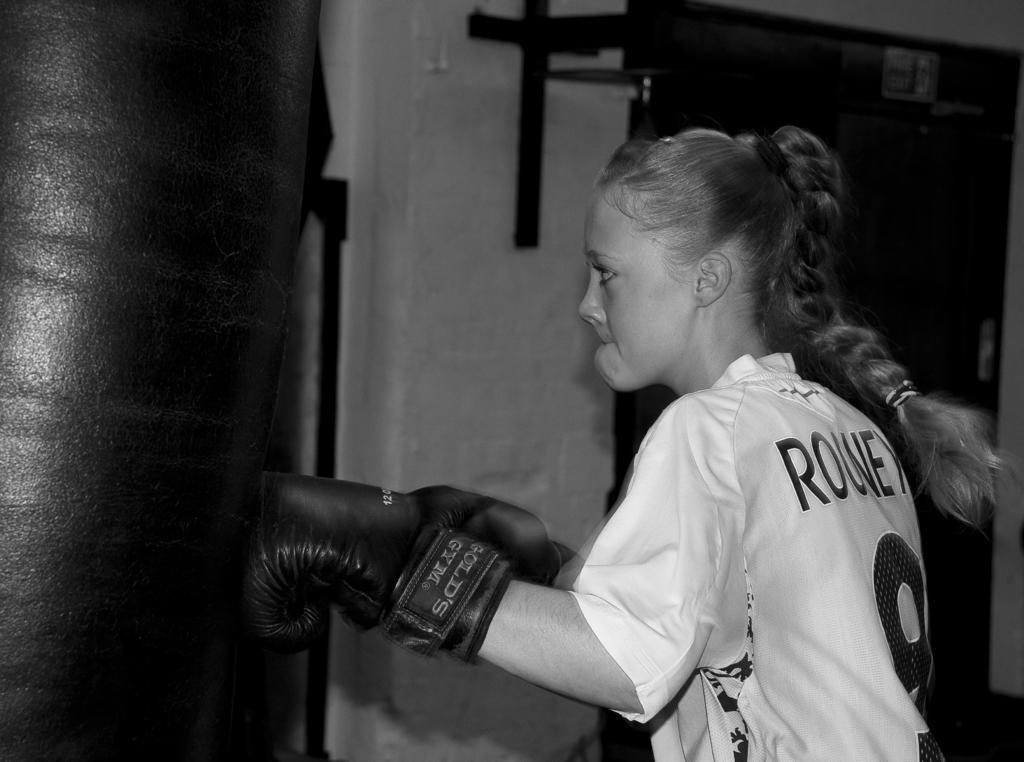Could you give a brief overview of what you see in this image? There is a girl on the right side of the image wearing boxing gloves and there is a punching bag on the left side, it seems like a door and metal object in the background area. 